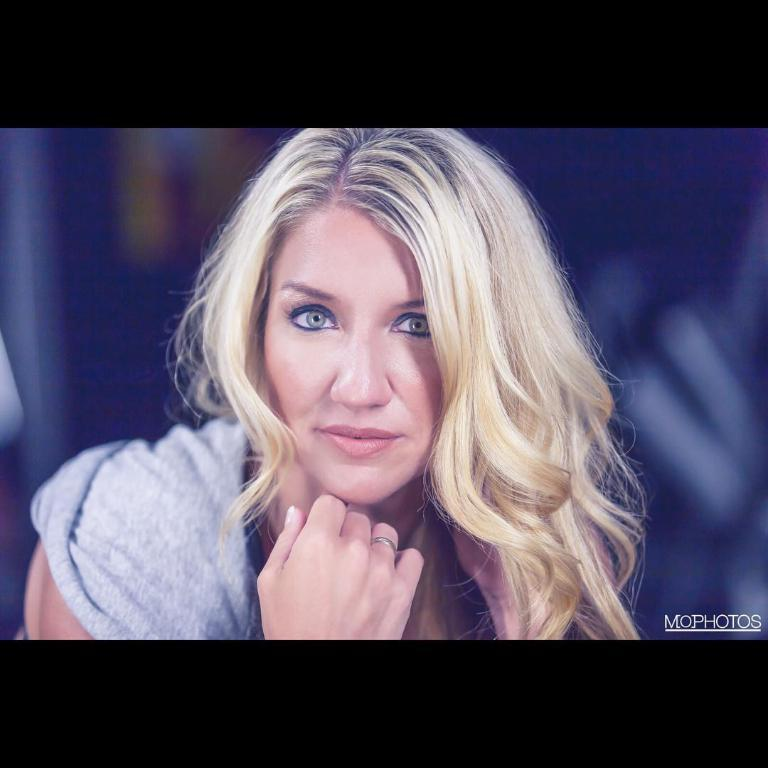Who is the main subject in the image? There is a woman in the image. What is a noticeable feature of the woman's appearance? The woman has cream-colored hair. What is the woman doing in the image? The woman is posing for a photo. How is the background of the image depicted? The background of the woman is blurred. What type of ticket does the woman have in her hand in the image? There is no ticket present in the image; the woman is posing for a photo. What is the woman cooking in the image? There is no cooking activity depicted in the image; the woman is posing for a photo. 